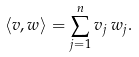Convert formula to latex. <formula><loc_0><loc_0><loc_500><loc_500>\langle v , w \rangle = \sum _ { j = 1 } ^ { n } v _ { j } \, w _ { j } .</formula> 